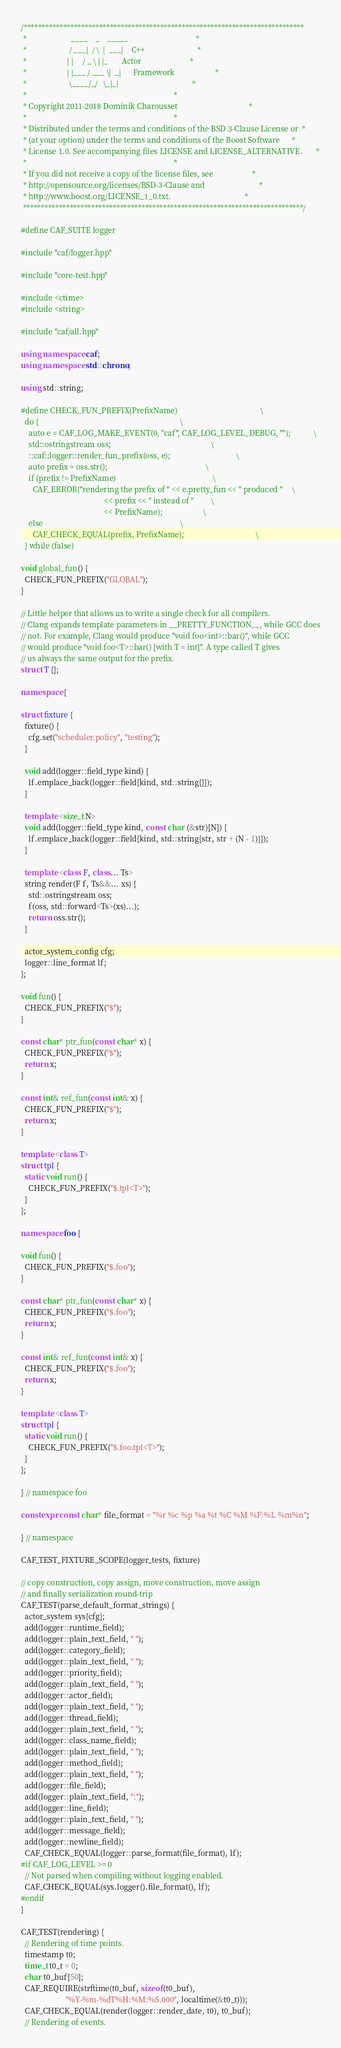Convert code to text. <code><loc_0><loc_0><loc_500><loc_500><_C++_>/******************************************************************************
 *                       ____    _    _____                                   *
 *                      / ___|  / \  |  ___|    C++                           *
 *                     | |     / _ \ | |_       Actor                         *
 *                     | |___ / ___ \|  _|      Framework                     *
 *                      \____/_/   \_|_|                                      *
 *                                                                            *
 * Copyright 2011-2018 Dominik Charousset                                     *
 *                                                                            *
 * Distributed under the terms and conditions of the BSD 3-Clause License or  *
 * (at your option) under the terms and conditions of the Boost Software      *
 * License 1.0. See accompanying files LICENSE and LICENSE_ALTERNATIVE.       *
 *                                                                            *
 * If you did not receive a copy of the license files, see                    *
 * http://opensource.org/licenses/BSD-3-Clause and                            *
 * http://www.boost.org/LICENSE_1_0.txt.                                      *
 ******************************************************************************/

#define CAF_SUITE logger

#include "caf/logger.hpp"

#include "core-test.hpp"

#include <ctime>
#include <string>

#include "caf/all.hpp"

using namespace caf;
using namespace std::chrono;

using std::string;

#define CHECK_FUN_PREFIX(PrefixName)                                           \
  do {                                                                         \
    auto e = CAF_LOG_MAKE_EVENT(0, "caf", CAF_LOG_LEVEL_DEBUG, "");            \
    std::ostringstream oss;                                                    \
    ::caf::logger::render_fun_prefix(oss, e);                                  \
    auto prefix = oss.str();                                                   \
    if (prefix != PrefixName)                                                  \
      CAF_ERROR("rendering the prefix of " << e.pretty_fun << " produced "     \
                                           << prefix << " instead of "         \
                                           << PrefixName);                     \
    else                                                                       \
      CAF_CHECK_EQUAL(prefix, PrefixName);                                     \
  } while (false)

void global_fun() {
  CHECK_FUN_PREFIX("GLOBAL");
}

// Little helper that allows us to write a single check for all compilers.
// Clang expands template parameters in __PRETTY_FUNCTION__, while GCC does
// not. For example, Clang would produce "void foo<int>::bar()", while GCC
// would produce "void foo<T>::bar() [with T = int]". A type called T gives
// us always the same output for the prefix.
struct T {};

namespace {

struct fixture {
  fixture() {
    cfg.set("scheduler.policy", "testing");
  }

  void add(logger::field_type kind) {
    lf.emplace_back(logger::field{kind, std::string{}});
  }

  template <size_t N>
  void add(logger::field_type kind, const char (&str)[N]) {
    lf.emplace_back(logger::field{kind, std::string{str, str + (N - 1)}});
  }

  template <class F, class... Ts>
  string render(F f, Ts&&... xs) {
    std::ostringstream oss;
    f(oss, std::forward<Ts>(xs)...);
    return oss.str();
  }

  actor_system_config cfg;
  logger::line_format lf;
};

void fun() {
  CHECK_FUN_PREFIX("$");
}

const char* ptr_fun(const char* x) {
  CHECK_FUN_PREFIX("$");
  return x;
}

const int& ref_fun(const int& x) {
  CHECK_FUN_PREFIX("$");
  return x;
}

template <class T>
struct tpl {
  static void run() {
    CHECK_FUN_PREFIX("$.tpl<T>");
  }
};

namespace foo {

void fun() {
  CHECK_FUN_PREFIX("$.foo");
}

const char* ptr_fun(const char* x) {
  CHECK_FUN_PREFIX("$.foo");
  return x;
}

const int& ref_fun(const int& x) {
  CHECK_FUN_PREFIX("$.foo");
  return x;
}

template <class T>
struct tpl {
  static void run() {
    CHECK_FUN_PREFIX("$.foo.tpl<T>");
  }
};

} // namespace foo

constexpr const char* file_format = "%r %c %p %a %t %C %M %F:%L %m%n";

} // namespace

CAF_TEST_FIXTURE_SCOPE(logger_tests, fixture)

// copy construction, copy assign, move construction, move assign
// and finally serialization round-trip
CAF_TEST(parse_default_format_strings) {
  actor_system sys{cfg};
  add(logger::runtime_field);
  add(logger::plain_text_field, " ");
  add(logger::category_field);
  add(logger::plain_text_field, " ");
  add(logger::priority_field);
  add(logger::plain_text_field, " ");
  add(logger::actor_field);
  add(logger::plain_text_field, " ");
  add(logger::thread_field);
  add(logger::plain_text_field, " ");
  add(logger::class_name_field);
  add(logger::plain_text_field, " ");
  add(logger::method_field);
  add(logger::plain_text_field, " ");
  add(logger::file_field);
  add(logger::plain_text_field, ":");
  add(logger::line_field);
  add(logger::plain_text_field, " ");
  add(logger::message_field);
  add(logger::newline_field);
  CAF_CHECK_EQUAL(logger::parse_format(file_format), lf);
#if CAF_LOG_LEVEL >= 0
  // Not parsed when compiling without logging enabled.
  CAF_CHECK_EQUAL(sys.logger().file_format(), lf);
#endif
}

CAF_TEST(rendering) {
  // Rendering of time points.
  timestamp t0;
  time_t t0_t = 0;
  char t0_buf[50];
  CAF_REQUIRE(strftime(t0_buf, sizeof(t0_buf),
                       "%Y-%m-%dT%H:%M:%S.000", localtime(&t0_t)));
  CAF_CHECK_EQUAL(render(logger::render_date, t0), t0_buf);
  // Rendering of events.</code> 